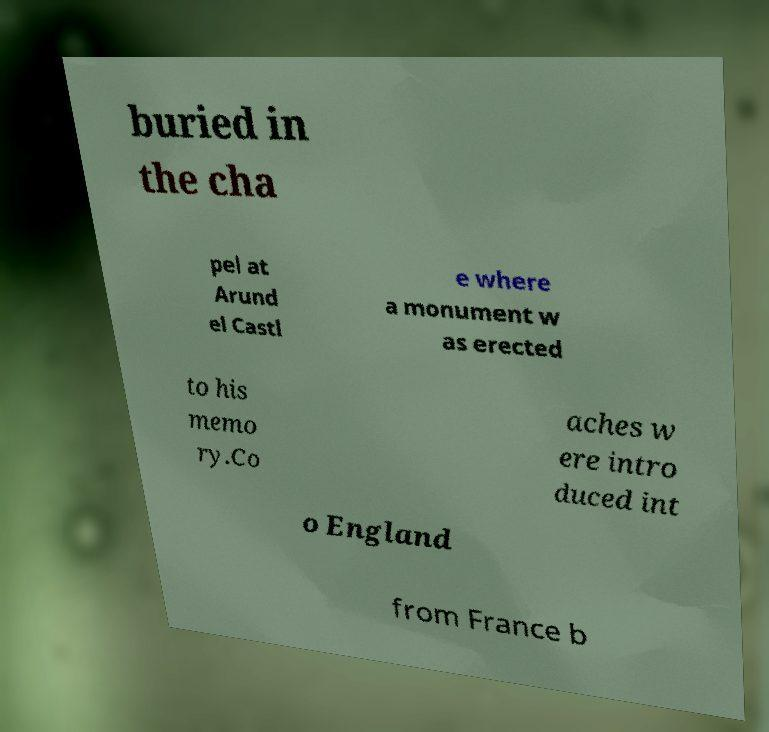Please identify and transcribe the text found in this image. buried in the cha pel at Arund el Castl e where a monument w as erected to his memo ry.Co aches w ere intro duced int o England from France b 